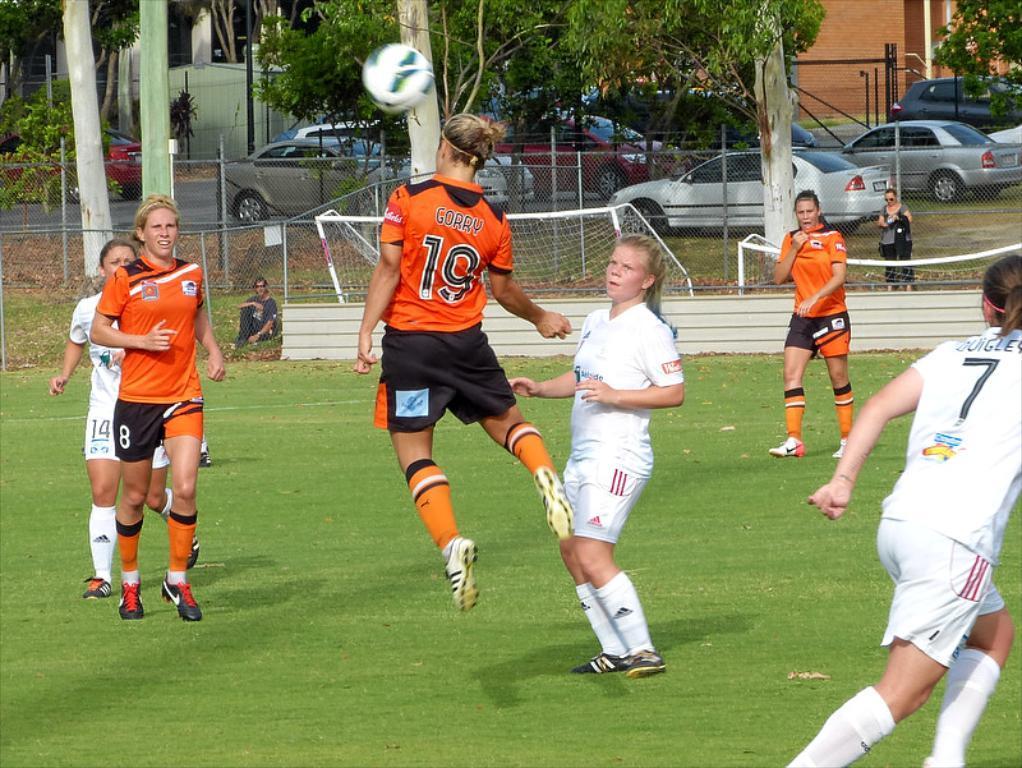Could you give a brief overview of what you see in this image? In this image, we can see there are persons in orange and white color T-shirts, playing football on the ground, on which there is grass. In the background, there is a net, there are two persons, vehicles, trees, plants and buildings. 